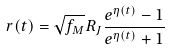Convert formula to latex. <formula><loc_0><loc_0><loc_500><loc_500>r ( t ) = \sqrt { f _ { M } } R _ { J } \frac { e ^ { \eta ( t ) } - 1 } { e ^ { \eta ( t ) } + 1 }</formula> 